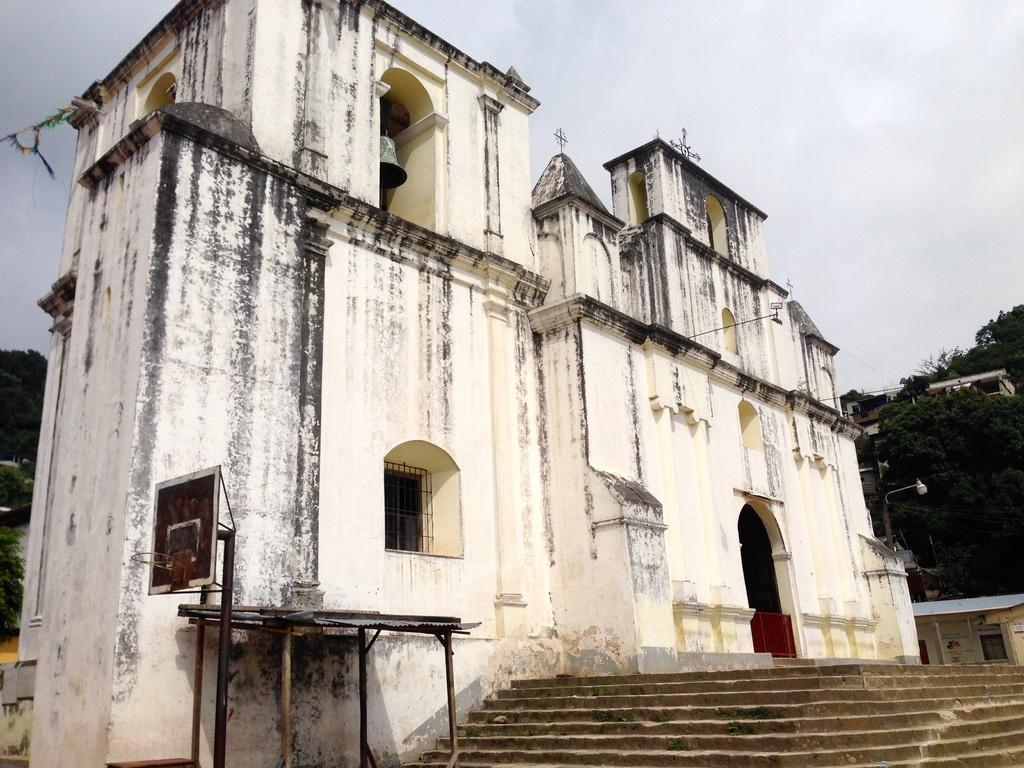What type of structures can be seen in the image? There are buildings in the image. What natural elements are present in the image? There are trees in the image. What man-made objects can be seen in the image? There are poles in the image. What object is associated with sound in the image? There is a bell in the image. What sports-related object is visible on the left side of the image? There is a basketball net on the left side of the image. Who is the owner of the existence in the image? There is no concept of ownership for the existence in the image, as it is a general term and not a specific object or entity. 